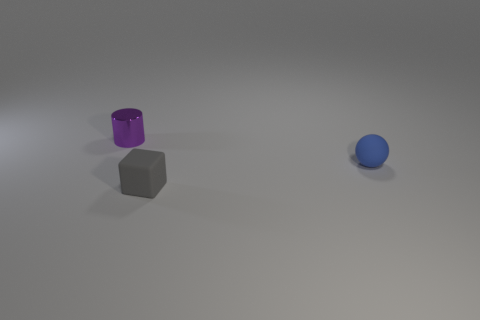Add 2 shiny things. How many objects exist? 5 Add 1 matte things. How many matte things are left? 3 Add 3 big yellow spheres. How many big yellow spheres exist? 3 Subtract 0 blue cubes. How many objects are left? 3 Subtract all balls. How many objects are left? 2 Subtract 1 cylinders. How many cylinders are left? 0 Subtract all cyan cubes. Subtract all yellow cylinders. How many cubes are left? 1 Subtract all balls. Subtract all red metal objects. How many objects are left? 2 